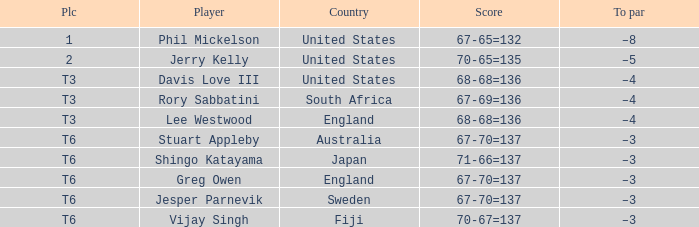Write the full table. {'header': ['Plc', 'Player', 'Country', 'Score', 'To par'], 'rows': [['1', 'Phil Mickelson', 'United States', '67-65=132', '–8'], ['2', 'Jerry Kelly', 'United States', '70-65=135', '–5'], ['T3', 'Davis Love III', 'United States', '68-68=136', '–4'], ['T3', 'Rory Sabbatini', 'South Africa', '67-69=136', '–4'], ['T3', 'Lee Westwood', 'England', '68-68=136', '–4'], ['T6', 'Stuart Appleby', 'Australia', '67-70=137', '–3'], ['T6', 'Shingo Katayama', 'Japan', '71-66=137', '–3'], ['T6', 'Greg Owen', 'England', '67-70=137', '–3'], ['T6', 'Jesper Parnevik', 'Sweden', '67-70=137', '–3'], ['T6', 'Vijay Singh', 'Fiji', '70-67=137', '–3']]} Name the place for score of 67-70=137 and stuart appleby T6. 